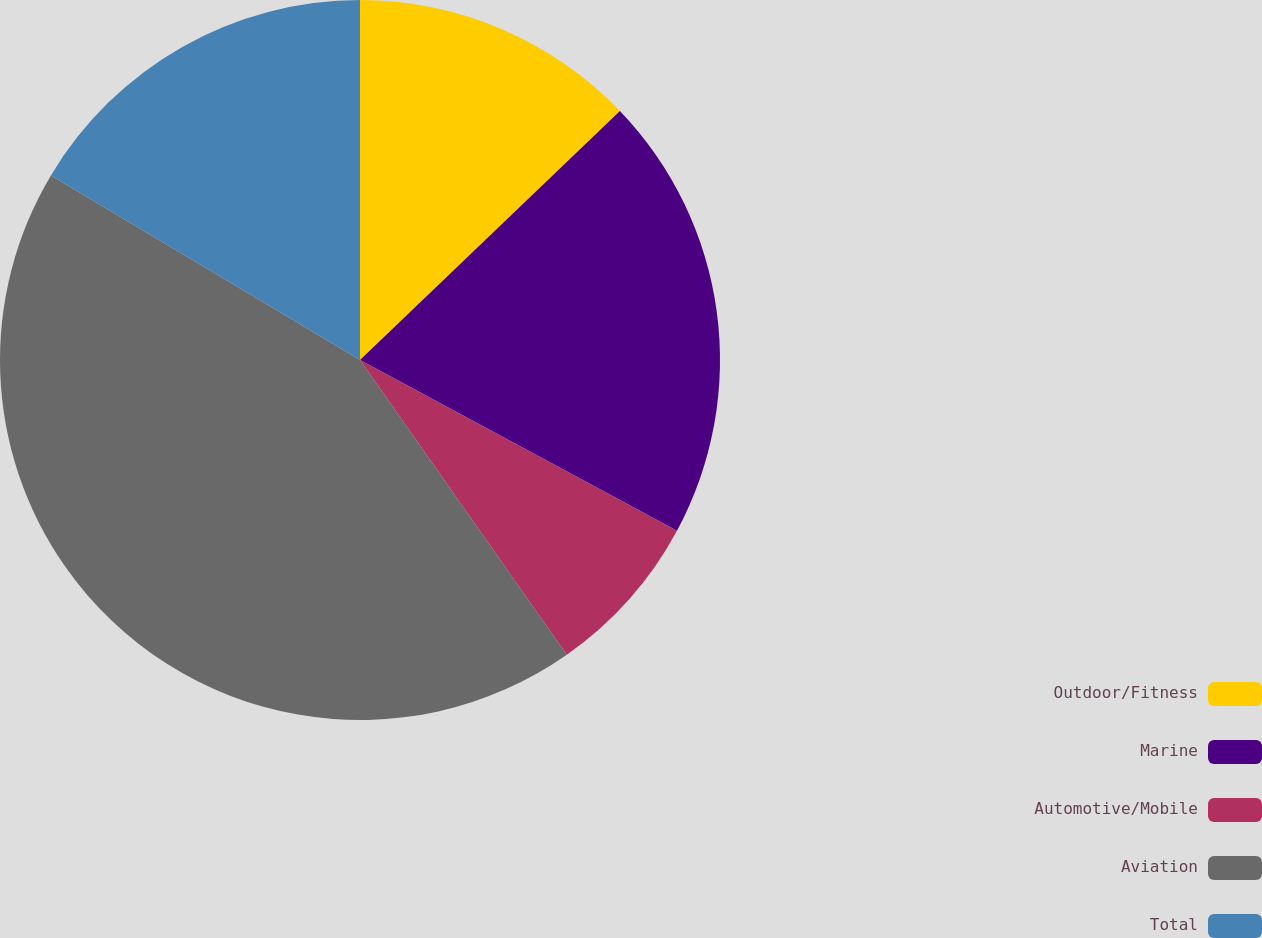Convert chart. <chart><loc_0><loc_0><loc_500><loc_500><pie_chart><fcel>Outdoor/Fitness<fcel>Marine<fcel>Automotive/Mobile<fcel>Aviation<fcel>Total<nl><fcel>12.84%<fcel>20.02%<fcel>7.4%<fcel>43.31%<fcel>16.43%<nl></chart> 